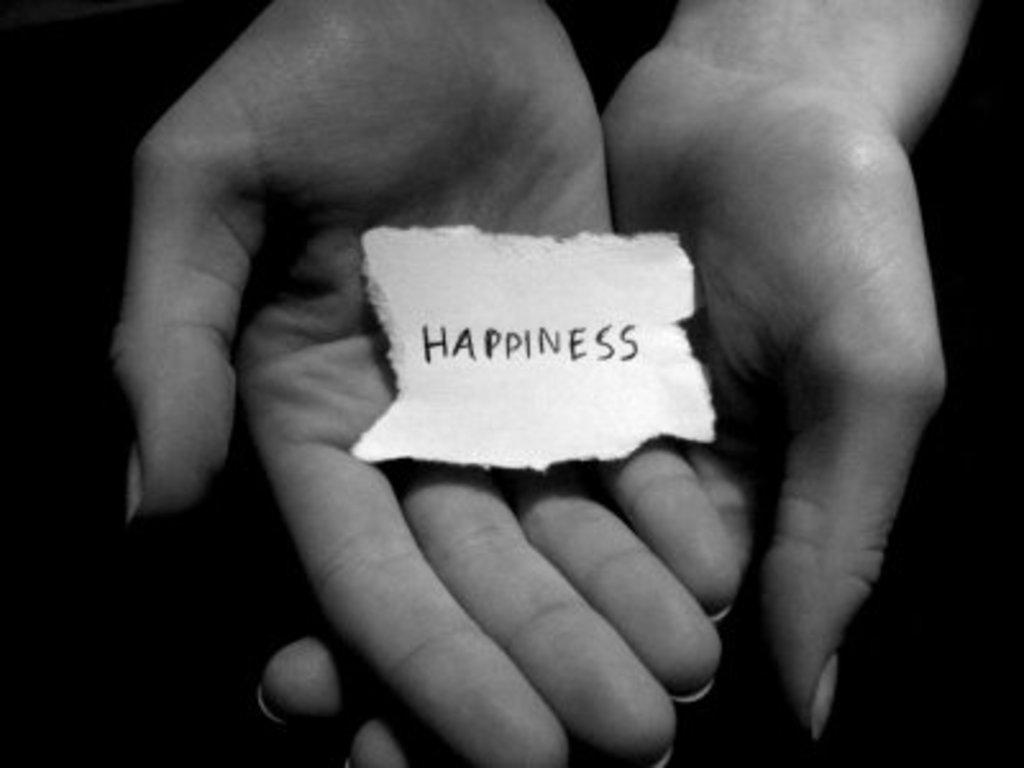What is the color scheme of the image? The image is black and white. What can be seen in the person's hands in the image? The person's hands are holding a piece of paper. What is on the piece of paper? There are written words on the piece of paper. What type of thread is being used to sew the shoe in the image? There is no shoe or thread present in the image; it features a person's hands holding a piece of paper with written words. What is the purpose of the person holding the paper in the image? The purpose of the person holding the paper in the image cannot be determined from the provided facts. 